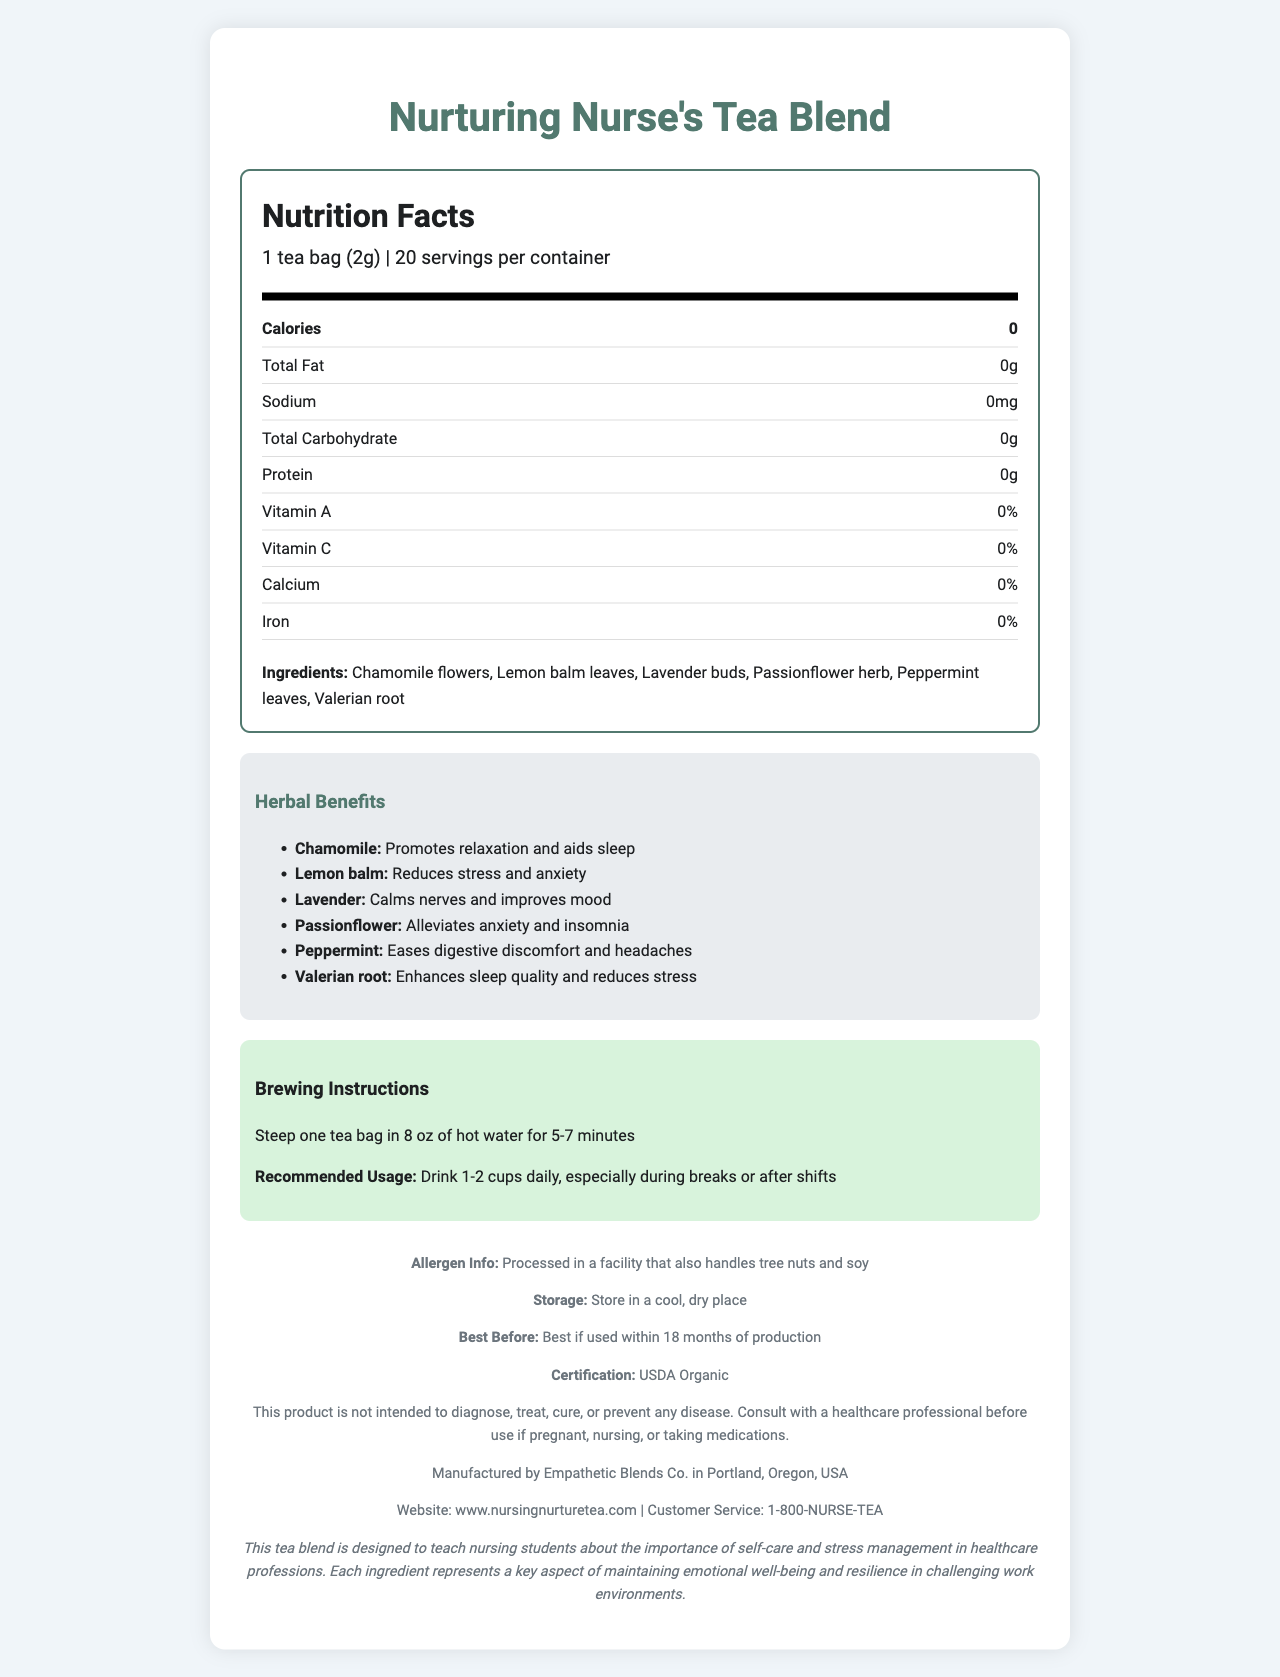What is the serving size of "Nurturing Nurse's Tea Blend"? The serving size is explicitly stated as "1 tea bag (2g)" in the nutrition facts.
Answer: 1 tea bag (2g) How many servings are there per container? The document indicates that there are 20 servings per container.
Answer: 20 servings What is the total calorie content per serving? Under "Nutrition Facts", it lists the calorie content as 0.
Answer: 0 calories Name two ingredients of "Nurturing Nurse's Tea Blend". Among the ingredients listed are "Chamomile flowers" and "Lemon balm leaves".
Answer: Chamomile flowers, Lemon balm leaves What does the valerian root help with? In the Herbal Benefits section, it states that Valerian root helps to enhance sleep quality and reduce stress.
Answer: Enhances sleep quality and reduces stress Which of the following ingredients is known for easing digestive discomfort and headaches? A. Chamomile B. Passionflower C. Peppermint D. Valerian root The document states that peppermint eases digestive discomfort and headaches.
Answer: C. Peppermint What must a person do if they are pregnant or nursing and want to use this product? A. Drink more tea B. Avoid the tea C. Consult a healthcare professional D. Steep the tea longer The disclaimer advises consulting a healthcare professional if pregnant or nursing.
Answer: C. Consult a healthcare professional Is the product gluten-free? The document does not provide any information on whether the product is gluten-free.
Answer: Not enough information Is Nurturing Nurse's Tea Blend USDA Organic certified? The document mentions that the product has USDA Organic certification.
Answer: Yes Summarize the main idea of the document. The document mainly describes a tea product meant for nurses, indicating its nutritional content, ingredients along with their health benefits, usage instructions, and relevant allergen and regulatory details. It emphasizes the product's role in education about self-care.
Answer: The document provides comprehensive information about "Nurturing Nurse's Tea Blend," including its nutrition facts, ingredients, herbal benefits, brewing instructions, and recommended usage. It also gives details on allergen info, storage, expiration, certification, and the manufacturer. The tea blend, featuring calming herbs, is designed to teach nursing students about the importance of self-care and stress management in healthcare professions. What is the recommended usage frequency for this tea? The recommended usage mentioned in the brewing instructions section is "Drink 1-2 cups daily, especially during breaks or after shifts."
Answer: Drink 1-2 cups daily, especially during breaks or after shifts What should be done if the tea blend is stored? The storage section advises to store the tea in a cool, dry place.
Answer: Store in a cool, dry place Which herb is noted for alleviating anxiety and insomnia? The herbal benefits state that passionflower alleviates anxiety and insomnia.
Answer: Passionflower herb Where is the manufacturer of the tea located? The document specifies that the manufacturer, Empathetic Blends Co., is located in Portland, Oregon, USA.
Answer: Portland, Oregon, USA What is the purpose of integrating this tea blend into the nursing curriculum? The educational note mentions that the tea blend is designed to teach nursing students about the importance of self-care and stress management in healthcare professions.
Answer: To teach nursing students about the importance of self-care and stress management in healthcare professions 